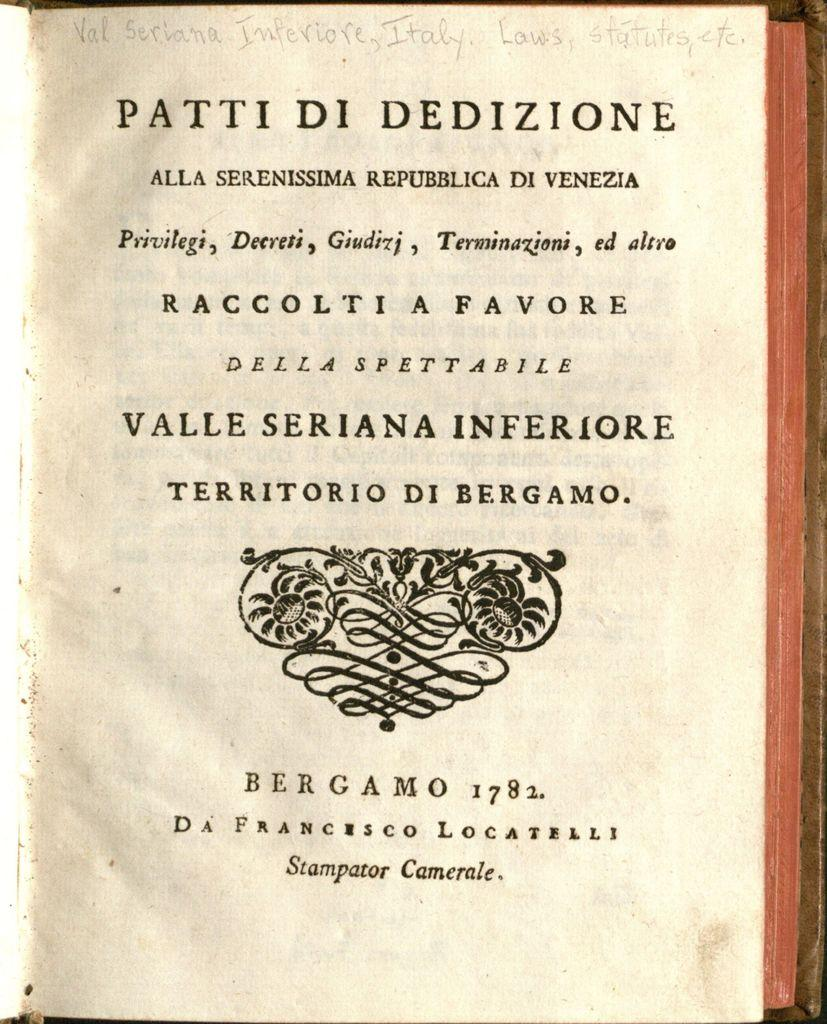<image>
Present a compact description of the photo's key features. The handwritten words at the top of the page include the country Italy. 